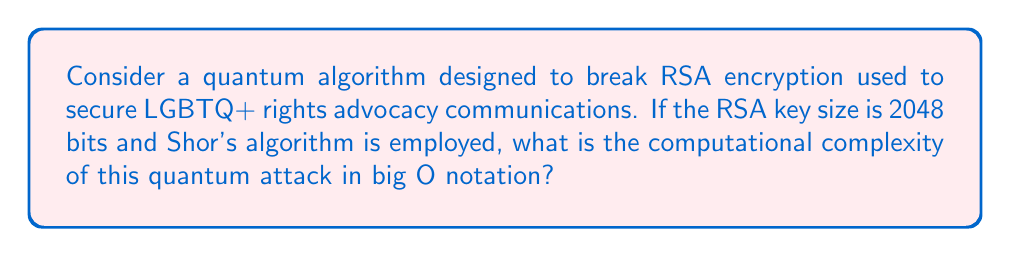Can you solve this math problem? To determine the computational complexity of Shor's algorithm for breaking RSA encryption, we'll follow these steps:

1. Understand the RSA key size:
   The given key size is 2048 bits, which means $n = 2^{2048}$ where $n$ is the RSA modulus.

2. Recall Shor's algorithm complexity:
   Shor's algorithm has a time complexity of $O((log N)^2 (log log N))$ for factoring an integer $N$.

3. Substitute the RSA modulus:
   In our case, $N = n = 2^{2048}$

4. Express the complexity in terms of the key size:
   Let $k$ be the key size in bits. Here, $k = 2048$.
   We can write $N = 2^k$

5. Rewrite the complexity:
   $O((log 2^k)^2 (log log 2^k))$

6. Simplify using logarithm properties:
   $O((k log 2)^2 (log (k log 2)))$
   $= O(k^2 (log k + log log 2))$

7. Asymptotic analysis:
   As $k$ grows large, $log log 2$ becomes negligible compared to $log k$.
   Therefore, we can simplify to:
   $O(k^2 log k)$

8. Substitute back the actual key size:
   With $k = 2048$, the final complexity is $O(2048^2 log 2048)$

This represents the number of quantum operations required to break the RSA encryption.
Answer: $O(k^2 log k)$, where $k$ is the key size in bits 